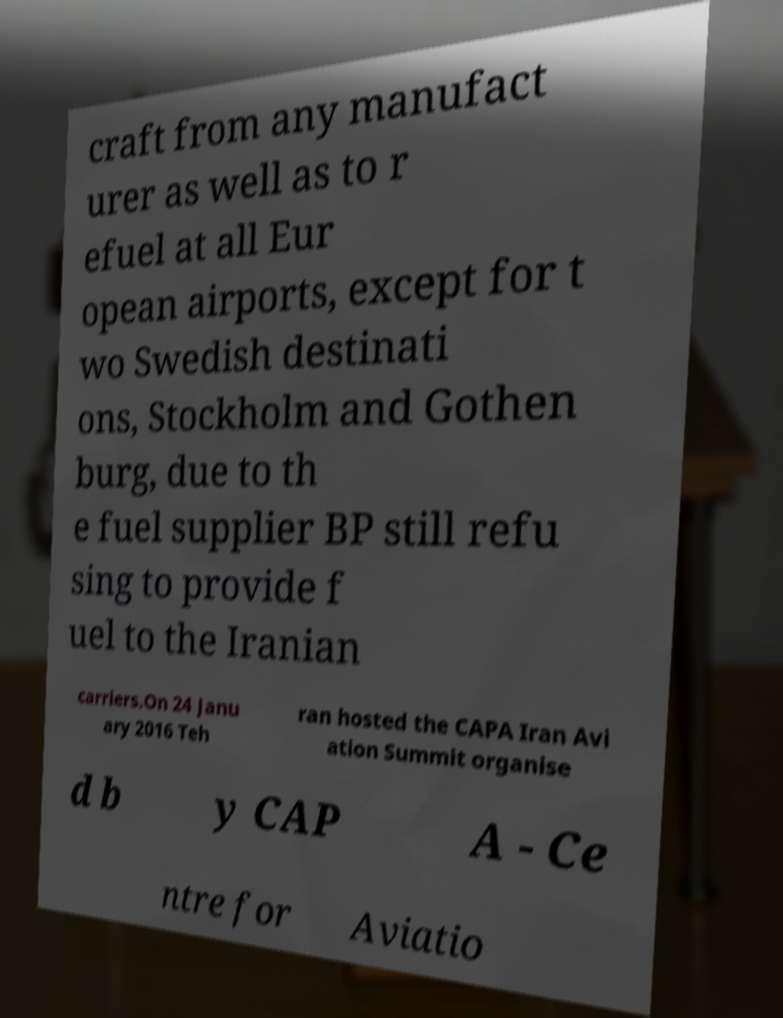For documentation purposes, I need the text within this image transcribed. Could you provide that? craft from any manufact urer as well as to r efuel at all Eur opean airports, except for t wo Swedish destinati ons, Stockholm and Gothen burg, due to th e fuel supplier BP still refu sing to provide f uel to the Iranian carriers.On 24 Janu ary 2016 Teh ran hosted the CAPA Iran Avi ation Summit organise d b y CAP A - Ce ntre for Aviatio 